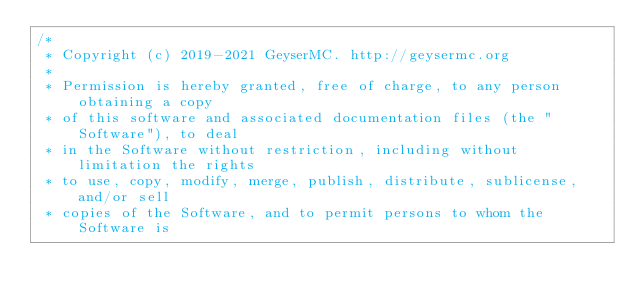Convert code to text. <code><loc_0><loc_0><loc_500><loc_500><_Java_>/*
 * Copyright (c) 2019-2021 GeyserMC. http://geysermc.org
 *
 * Permission is hereby granted, free of charge, to any person obtaining a copy
 * of this software and associated documentation files (the "Software"), to deal
 * in the Software without restriction, including without limitation the rights
 * to use, copy, modify, merge, publish, distribute, sublicense, and/or sell
 * copies of the Software, and to permit persons to whom the Software is</code> 